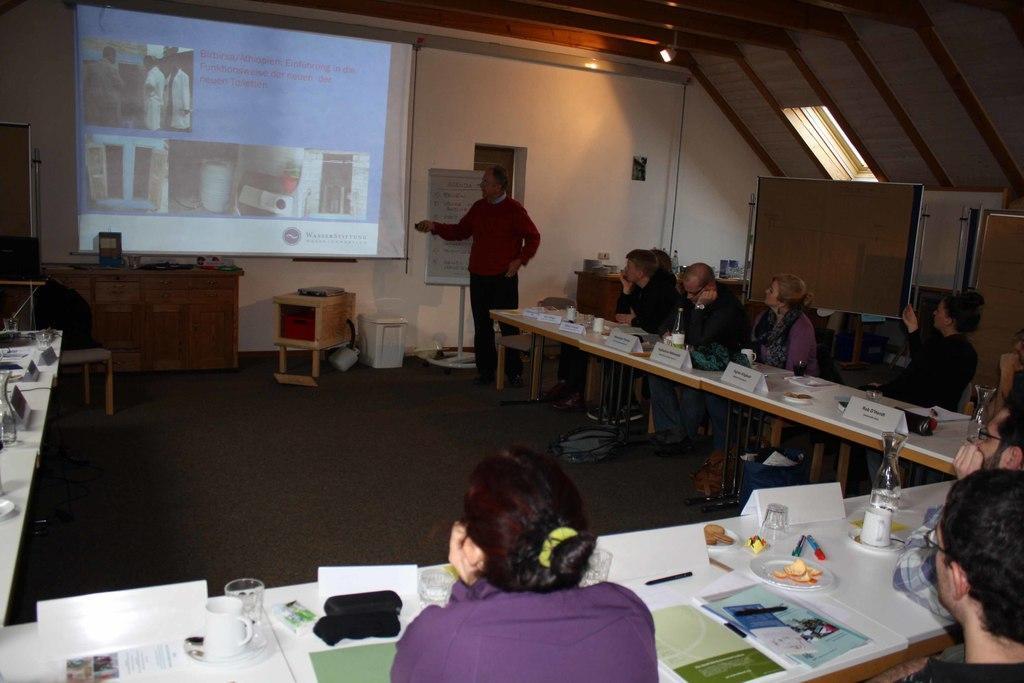In one or two sentences, can you explain what this image depicts? In this picture we can see some people sitting on the chairs in front of the table on which there are some things like name boards, plates, books, glasses and in front of them there is a man who is standing is holding the remote of a projector screen and opposite to them there is a projector screen and a desk on which some things are placed. 